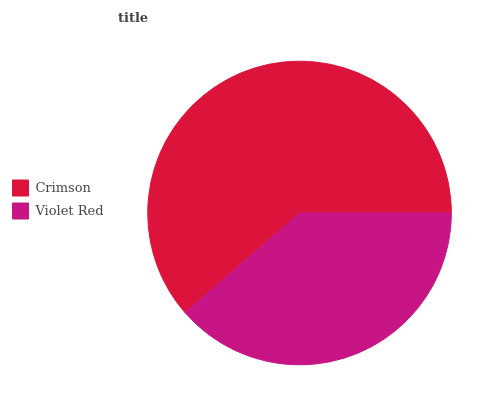Is Violet Red the minimum?
Answer yes or no. Yes. Is Crimson the maximum?
Answer yes or no. Yes. Is Violet Red the maximum?
Answer yes or no. No. Is Crimson greater than Violet Red?
Answer yes or no. Yes. Is Violet Red less than Crimson?
Answer yes or no. Yes. Is Violet Red greater than Crimson?
Answer yes or no. No. Is Crimson less than Violet Red?
Answer yes or no. No. Is Crimson the high median?
Answer yes or no. Yes. Is Violet Red the low median?
Answer yes or no. Yes. Is Violet Red the high median?
Answer yes or no. No. Is Crimson the low median?
Answer yes or no. No. 